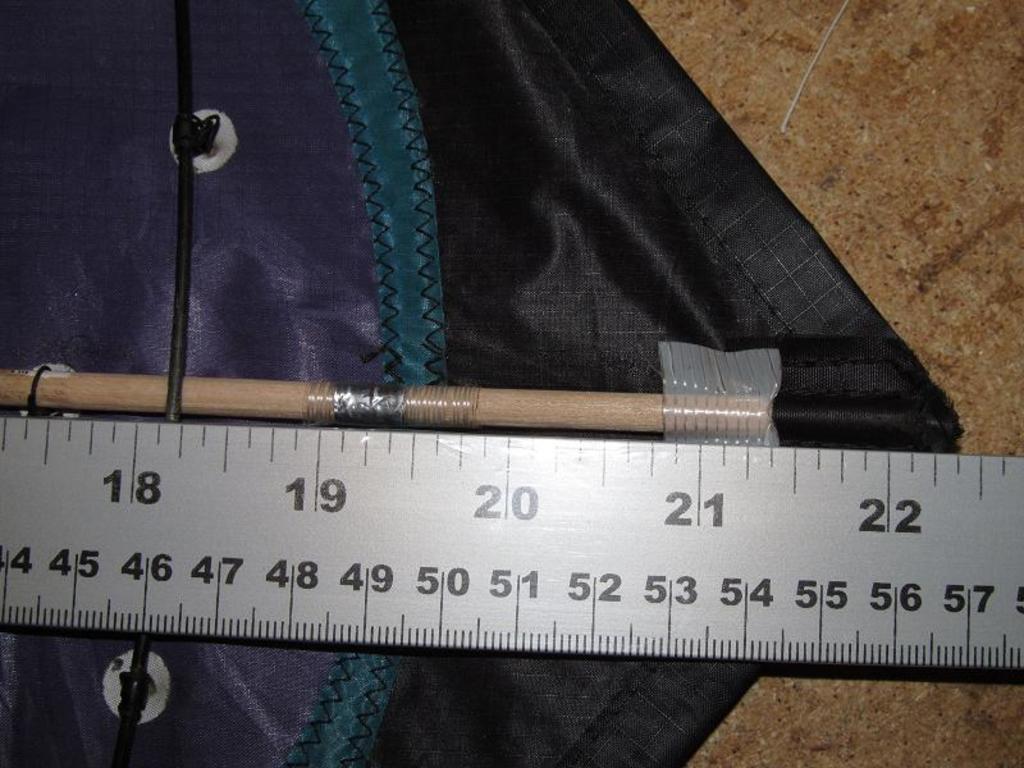What is the number in the middle of the top half of the ruler?
Give a very brief answer. 20. Is this ruler more than 22cm?
Ensure brevity in your answer.  Yes. 